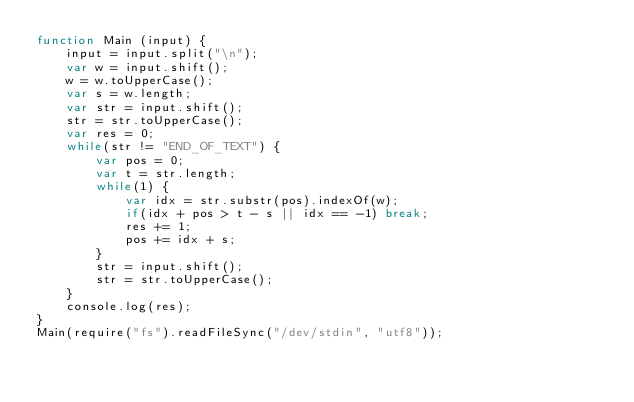<code> <loc_0><loc_0><loc_500><loc_500><_JavaScript_>function Main (input) {
    input = input.split("\n");
    var w = input.shift();
    w = w.toUpperCase();
    var s = w.length;
    var str = input.shift();
    str = str.toUpperCase();
    var res = 0;
    while(str != "END_OF_TEXT") {
        var pos = 0;
        var t = str.length;
        while(1) {
            var idx = str.substr(pos).indexOf(w);
            if(idx + pos > t - s || idx == -1) break;
            res += 1;
            pos += idx + s;
        }
        str = input.shift();
        str = str.toUpperCase();
    }
    console.log(res);
}
Main(require("fs").readFileSync("/dev/stdin", "utf8"));</code> 